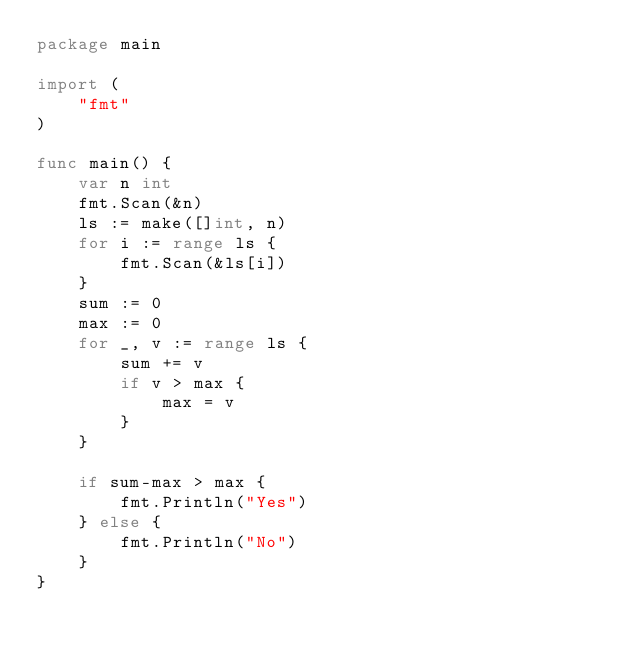<code> <loc_0><loc_0><loc_500><loc_500><_Go_>package main

import (
	"fmt"
)

func main() {
	var n int
	fmt.Scan(&n)
	ls := make([]int, n)
	for i := range ls {
		fmt.Scan(&ls[i])
	}
	sum := 0
	max := 0
	for _, v := range ls {
		sum += v
		if v > max {
			max = v
		}
	}

	if sum-max > max {
		fmt.Println("Yes")
	} else {
		fmt.Println("No")
	}
}
</code> 